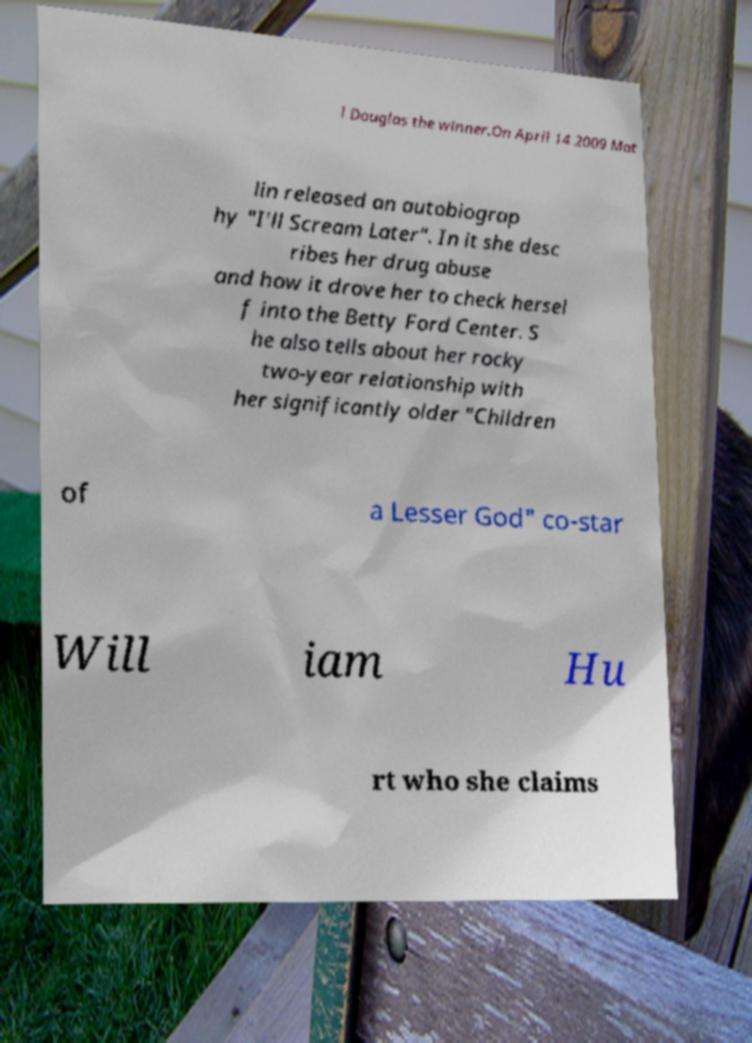Can you accurately transcribe the text from the provided image for me? l Douglas the winner.On April 14 2009 Mat lin released an autobiograp hy "I'll Scream Later". In it she desc ribes her drug abuse and how it drove her to check hersel f into the Betty Ford Center. S he also tells about her rocky two-year relationship with her significantly older "Children of a Lesser God" co-star Will iam Hu rt who she claims 